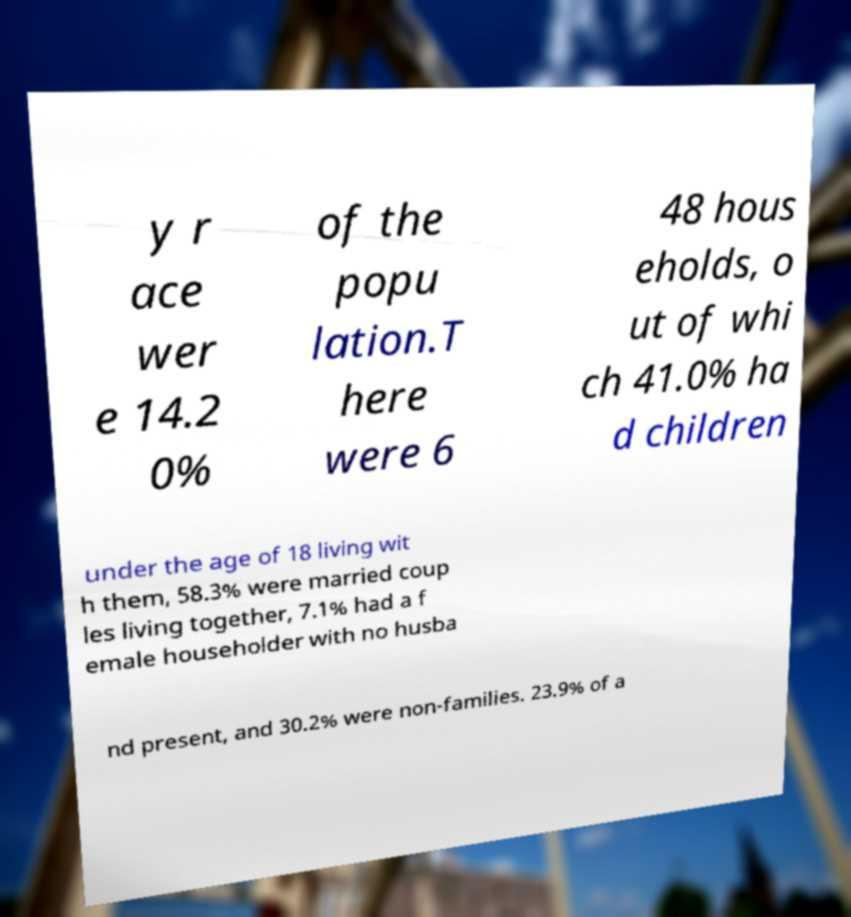For documentation purposes, I need the text within this image transcribed. Could you provide that? y r ace wer e 14.2 0% of the popu lation.T here were 6 48 hous eholds, o ut of whi ch 41.0% ha d children under the age of 18 living wit h them, 58.3% were married coup les living together, 7.1% had a f emale householder with no husba nd present, and 30.2% were non-families. 23.9% of a 